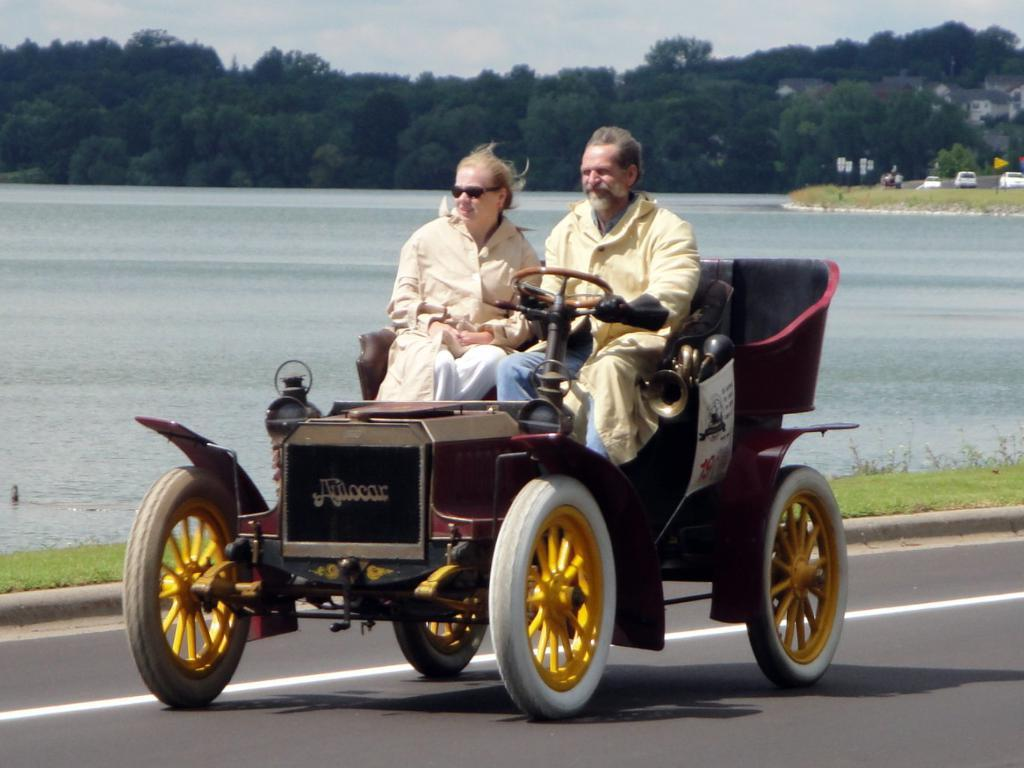What is the main subject of the picture? The main subject of the picture is a vehicle. Who is riding the vehicle? A man is riding the vehicle. Who is sitting beside the man? A woman is sitting beside the man. What can be seen in the background of the picture? There is a lake, trees, other vehicles, and the sky visible in the background of the picture. What type of print can be seen on the scarecrow's ear in the image? There is no scarecrow or ear present in the image, so no such print can be observed. 